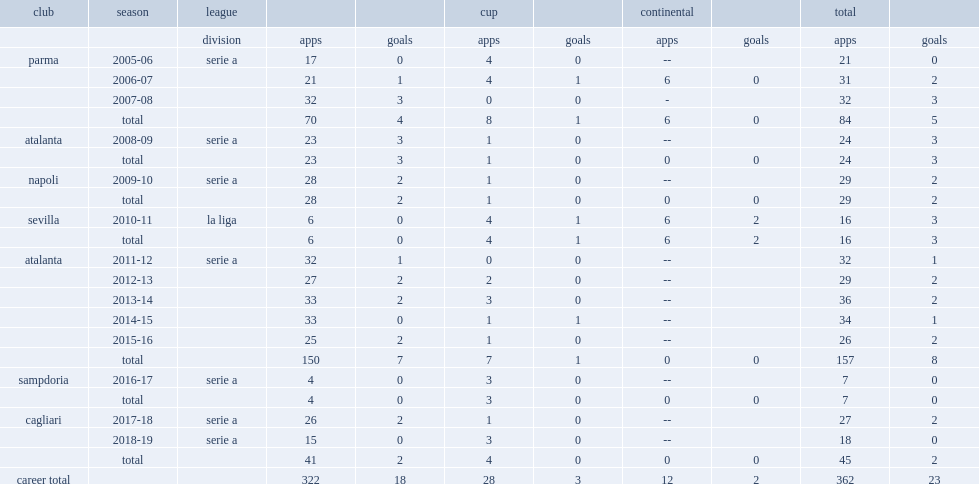Which club did luca cigarini play for in 2013-14? Atalanta. 